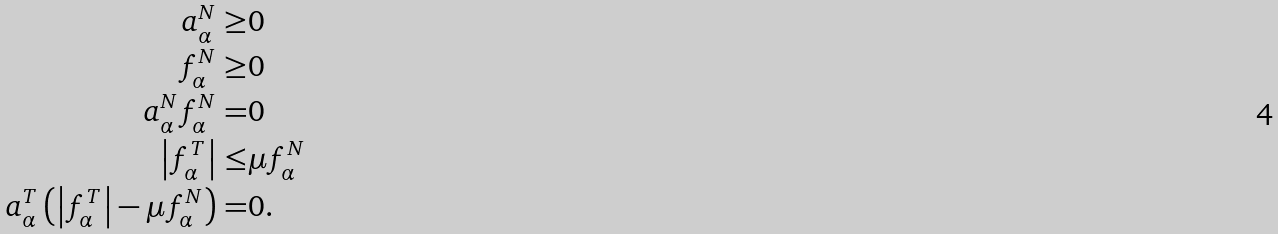<formula> <loc_0><loc_0><loc_500><loc_500>a _ { \alpha } ^ { N } \geq & 0 \\ f _ { \alpha } ^ { N } \geq & 0 \\ a _ { \alpha } ^ { N } f _ { \alpha } ^ { N } = & 0 \\ \left | f _ { \alpha } ^ { T } \right | \leq & \mu f _ { \alpha } ^ { N } \\ a _ { \alpha } ^ { T } \left ( \left | f _ { \alpha } ^ { T } \right | - \mu f _ { \alpha } ^ { N } \right ) = & 0 .</formula> 